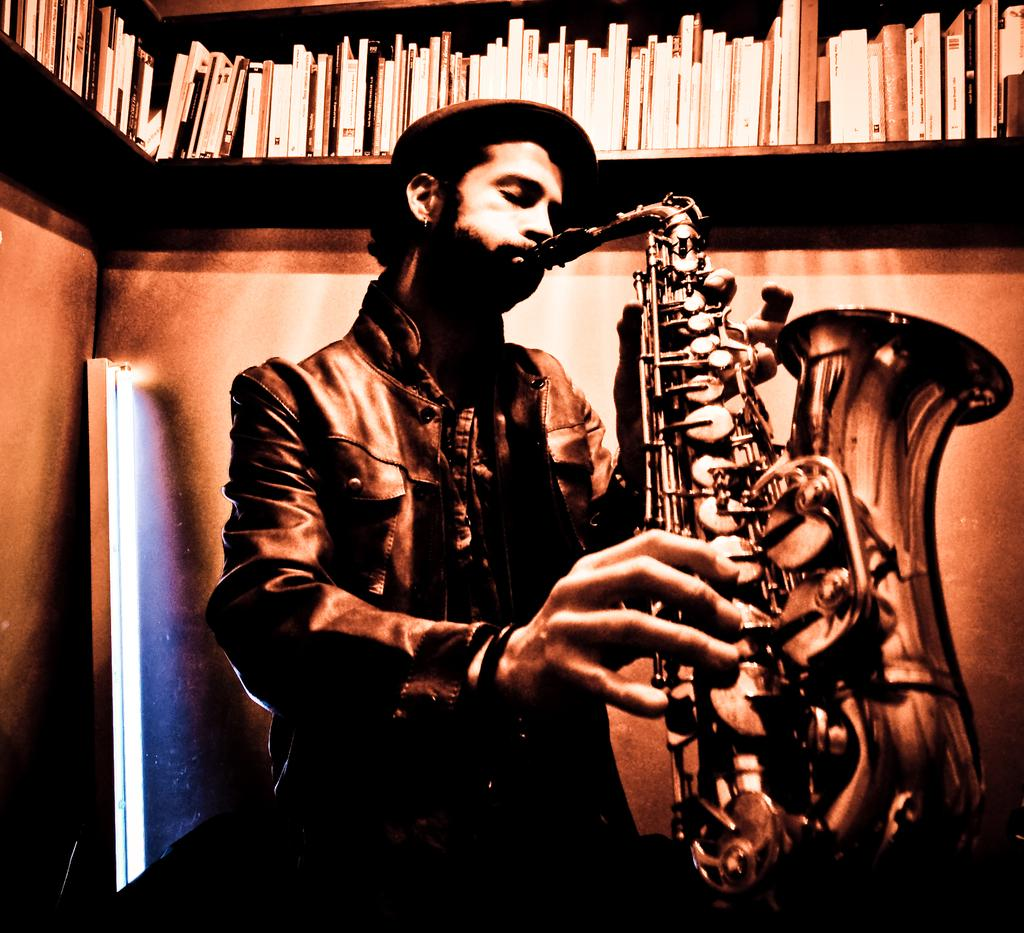What is the person in the image doing? The person in the image is playing a musical instrument. Can you describe the background of the image? There is an object in the background of the image, and there is a wall with shelves. What can be found on the shelves in the background of the image? There are books on the shelves in the background of the image. How many pizzas are being served with a fork in the image? There are no pizzas or forks present in the image. 